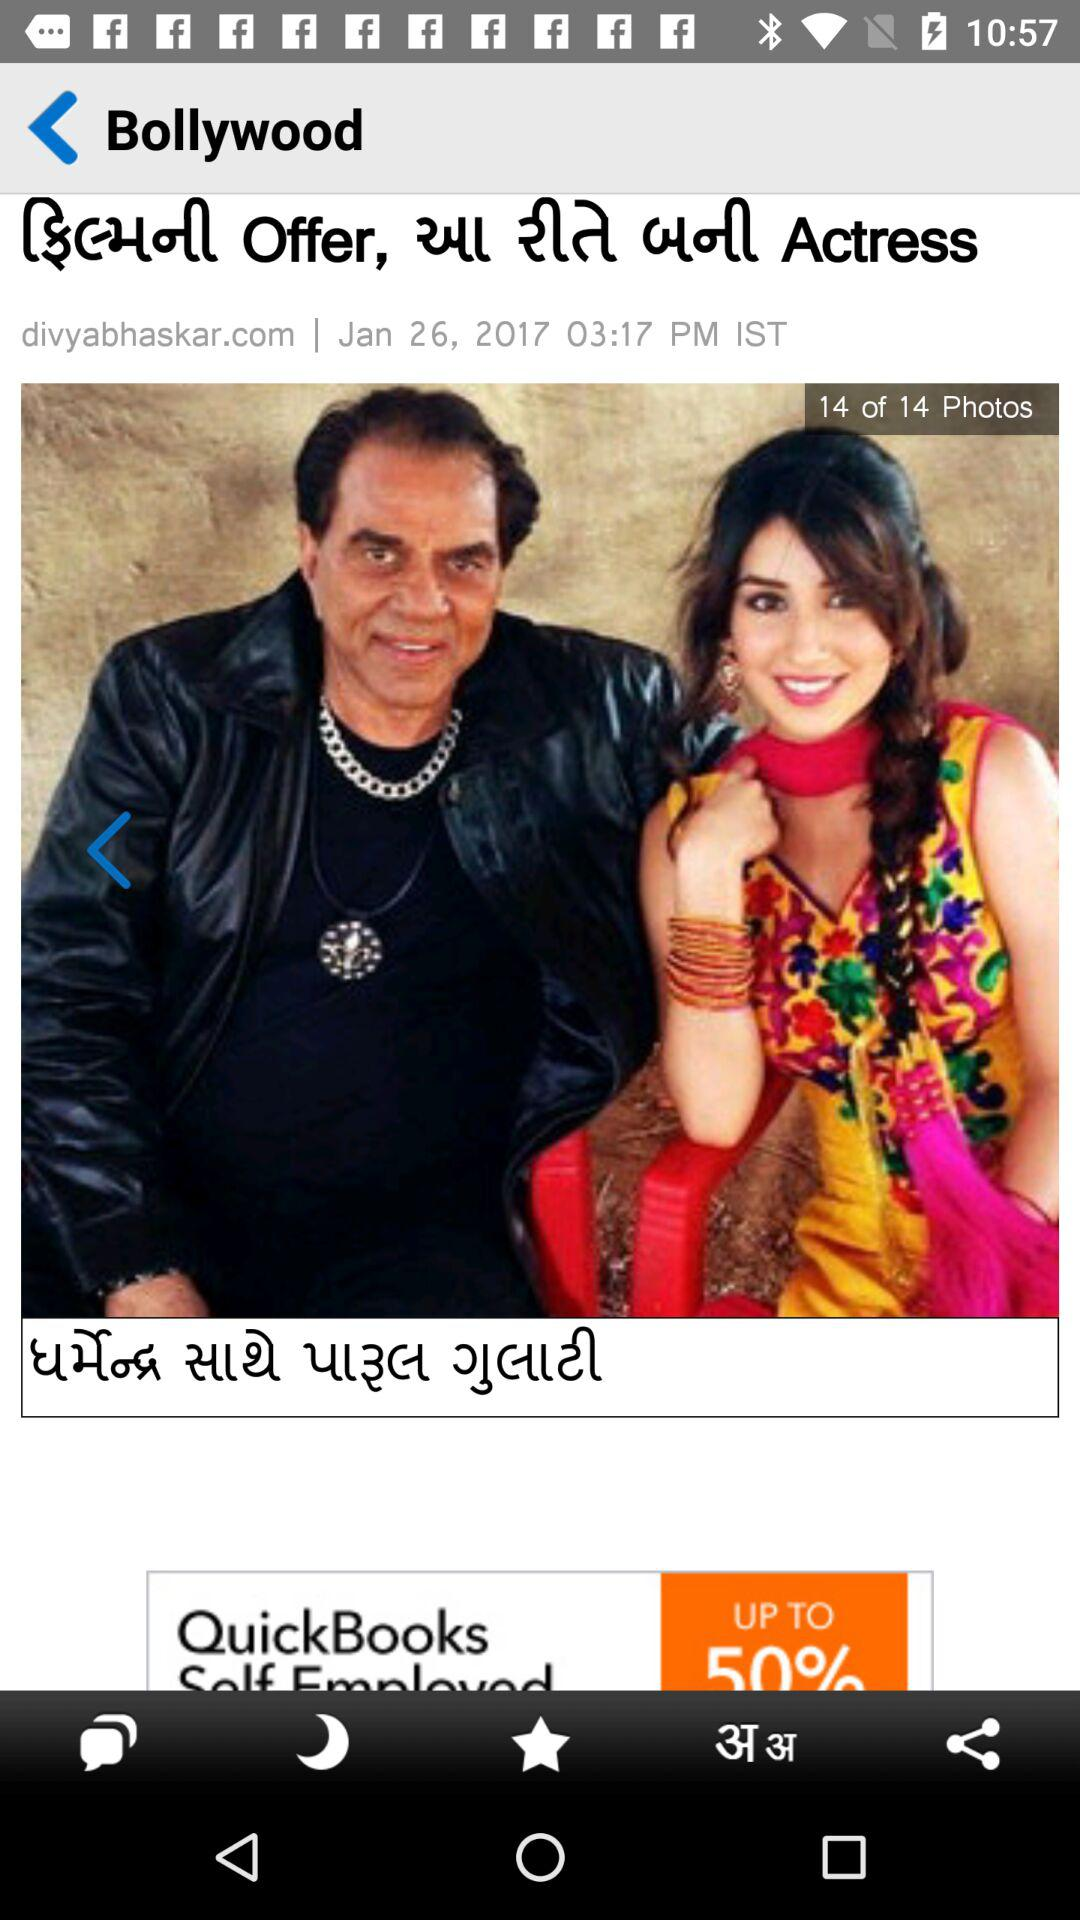How many photos are in the gallery?
Answer the question using a single word or phrase. 14 